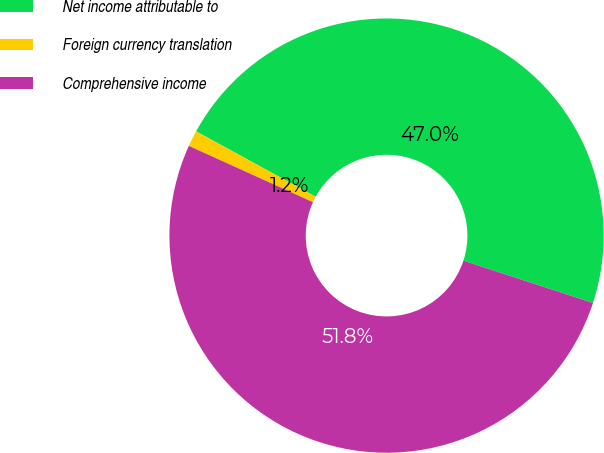Convert chart to OTSL. <chart><loc_0><loc_0><loc_500><loc_500><pie_chart><fcel>Net income attributable to<fcel>Foreign currency translation<fcel>Comprehensive income<nl><fcel>47.05%<fcel>1.19%<fcel>51.76%<nl></chart> 